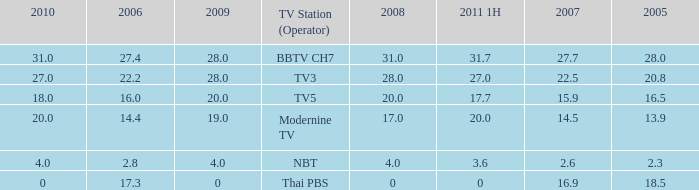What is the average 2007 value for a 2006 of 2.8 and 2009 under 20? 2.6. 